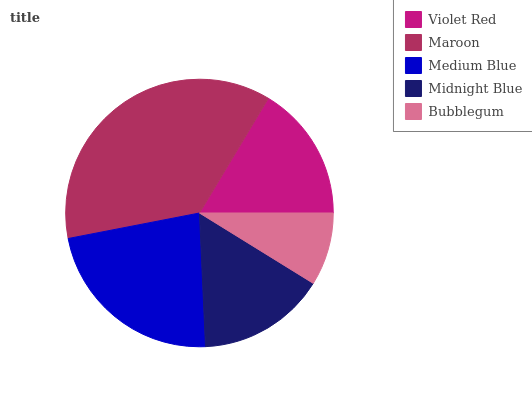Is Bubblegum the minimum?
Answer yes or no. Yes. Is Maroon the maximum?
Answer yes or no. Yes. Is Medium Blue the minimum?
Answer yes or no. No. Is Medium Blue the maximum?
Answer yes or no. No. Is Maroon greater than Medium Blue?
Answer yes or no. Yes. Is Medium Blue less than Maroon?
Answer yes or no. Yes. Is Medium Blue greater than Maroon?
Answer yes or no. No. Is Maroon less than Medium Blue?
Answer yes or no. No. Is Violet Red the high median?
Answer yes or no. Yes. Is Violet Red the low median?
Answer yes or no. Yes. Is Midnight Blue the high median?
Answer yes or no. No. Is Medium Blue the low median?
Answer yes or no. No. 